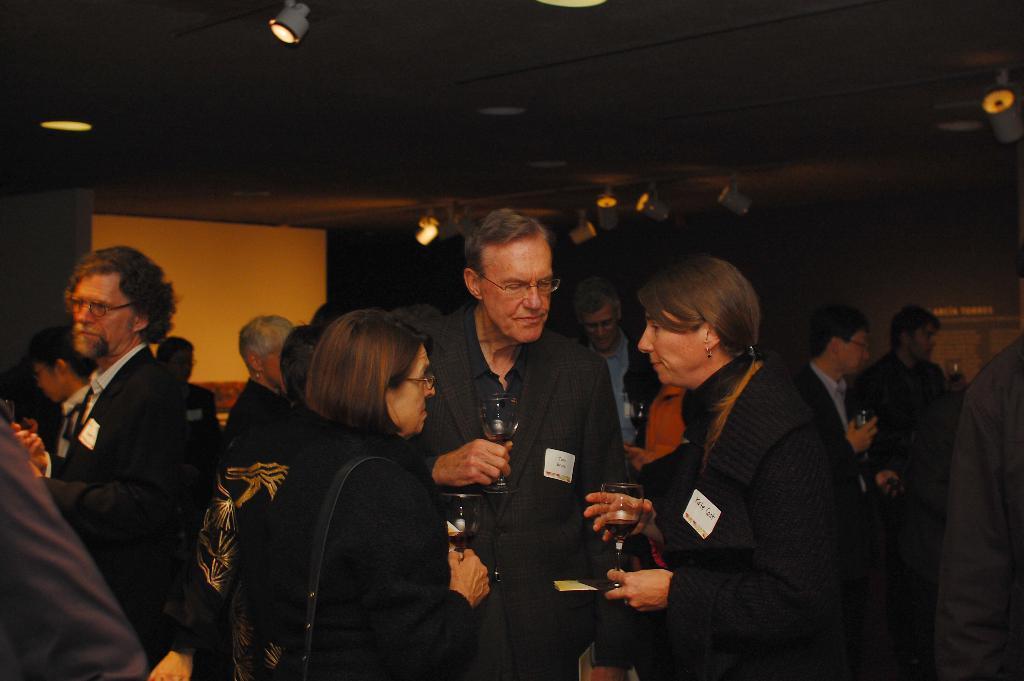Could you give a brief overview of what you see in this image? In the image in the center we can see few people were standing and they were holding wine glasses. In the background there is a wall,roof,board and lights. 